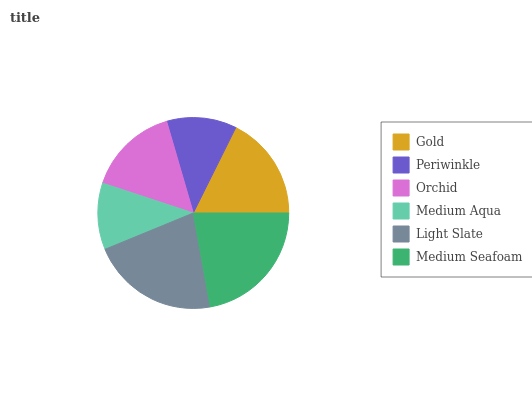Is Medium Aqua the minimum?
Answer yes or no. Yes. Is Medium Seafoam the maximum?
Answer yes or no. Yes. Is Periwinkle the minimum?
Answer yes or no. No. Is Periwinkle the maximum?
Answer yes or no. No. Is Gold greater than Periwinkle?
Answer yes or no. Yes. Is Periwinkle less than Gold?
Answer yes or no. Yes. Is Periwinkle greater than Gold?
Answer yes or no. No. Is Gold less than Periwinkle?
Answer yes or no. No. Is Gold the high median?
Answer yes or no. Yes. Is Orchid the low median?
Answer yes or no. Yes. Is Periwinkle the high median?
Answer yes or no. No. Is Medium Aqua the low median?
Answer yes or no. No. 